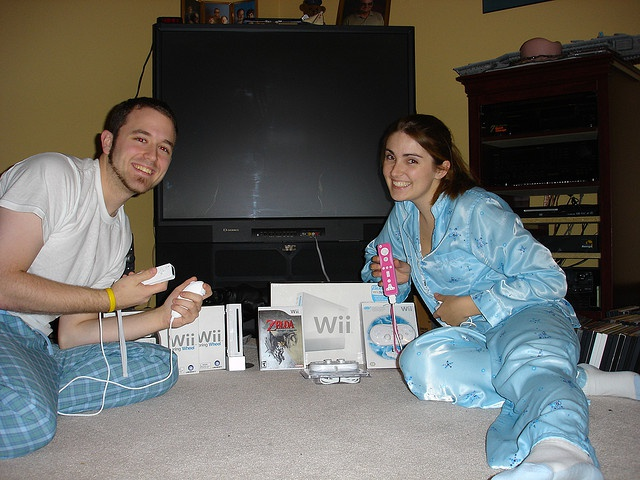Describe the objects in this image and their specific colors. I can see tv in maroon, black, gray, and purple tones, people in maroon, gray, and lightblue tones, people in maroon, darkgray, gray, and lightgray tones, remote in maroon, violet, lightgray, and brown tones, and remote in maroon, lightgray, darkgray, and gray tones in this image. 